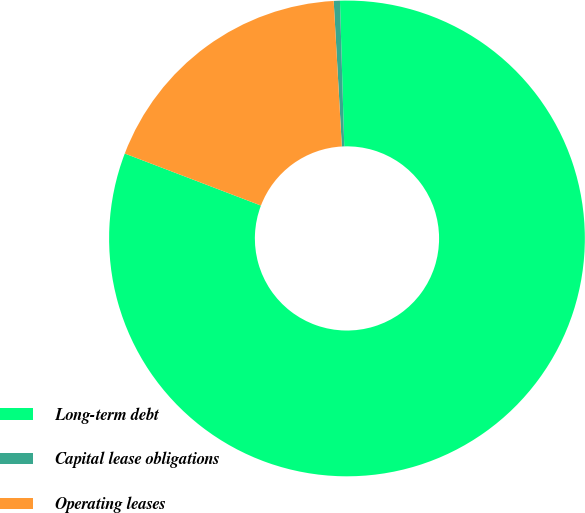Convert chart to OTSL. <chart><loc_0><loc_0><loc_500><loc_500><pie_chart><fcel>Long-term debt<fcel>Capital lease obligations<fcel>Operating leases<nl><fcel>81.28%<fcel>0.42%<fcel>18.3%<nl></chart> 